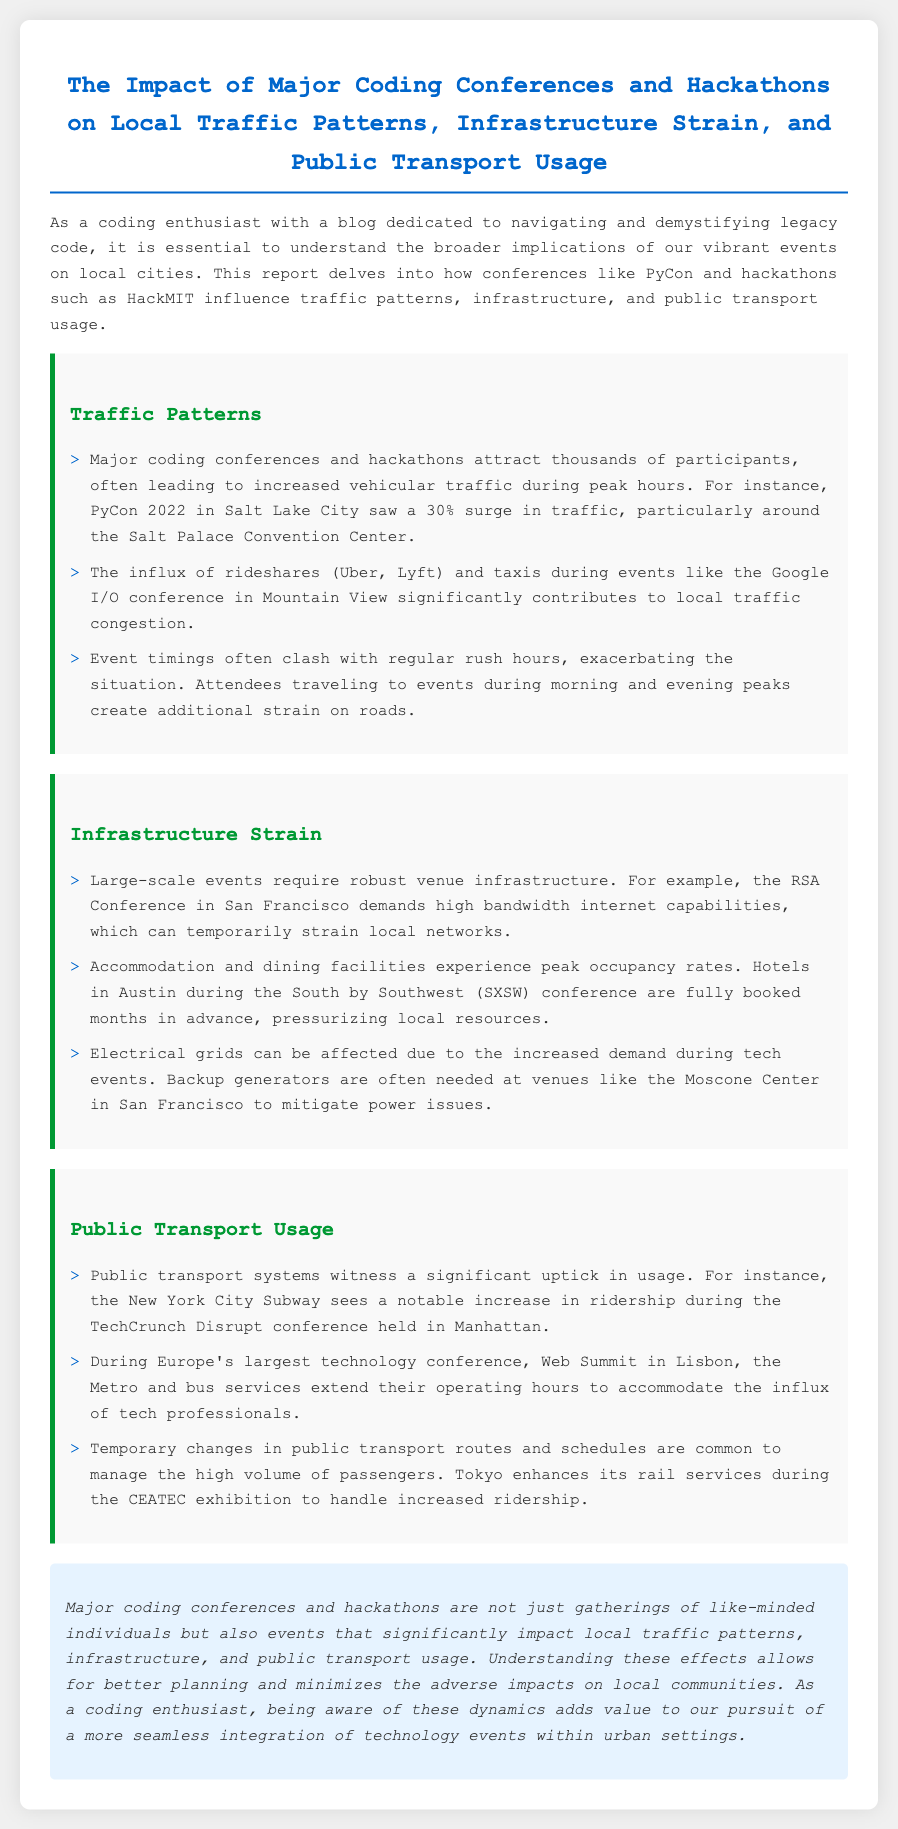What surge in traffic was noted during PyCon 2022? The document states that PyCon 2022 in Salt Lake City saw a 30% surge in traffic.
Answer: 30% What event caused a significant increase in usage of the New York City Subway? The report mentions that the TechCrunch Disrupt conference held in Manhattan caused a notable increase in subway ridership.
Answer: TechCrunch Disrupt Which conference is mentioned as experiencing peak occupancy rates for hotels in Austin? The document points out that during the South by Southwest (SXSW) conference, hotels in Austin are fully booked months in advance.
Answer: South by Southwest What infrastructure issue does the RSA Conference in San Francisco create? The document indicates that the RSA Conference demands high bandwidth internet capabilities, straining local networks.
Answer: High bandwidth internet What type of transport adjustments are made during the CEATEC exhibition? The report notes that Tokyo enhances its rail services during the CEATEC exhibition to handle increased ridership.
Answer: Rail services How does public transport respond to the Web Summit in Lisbon? The document mentions that Metro and bus services extend their operating hours during the Web Summit.
Answer: Extend operating hours What is the primary focus of the report? The document's introduction states that it delves into the impacts of coding conferences and hackathons on local traffic.
Answer: Impacts on local traffic What type of events are highlighted in the report? The report emphasizes major coding conferences and hackathons.
Answer: Major coding conferences and hackathons How do rideshares affect local traffic during events? The report mentions that rideshares significantly contribute to local traffic congestion during events like Google I/O.
Answer: Local traffic congestion 